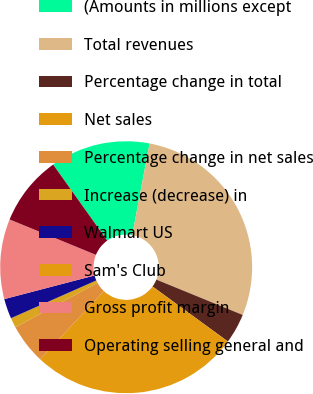Convert chart. <chart><loc_0><loc_0><loc_500><loc_500><pie_chart><fcel>(Amounts in millions except<fcel>Total revenues<fcel>Percentage change in total<fcel>Net sales<fcel>Percentage change in net sales<fcel>Increase (decrease) in<fcel>Walmart US<fcel>Sam's Club<fcel>Gross profit margin<fcel>Operating selling general and<nl><fcel>12.82%<fcel>28.21%<fcel>3.85%<fcel>26.92%<fcel>5.13%<fcel>1.28%<fcel>2.56%<fcel>0.0%<fcel>10.26%<fcel>8.97%<nl></chart> 